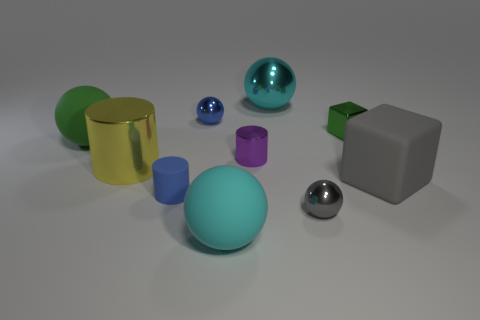What material is the purple object?
Give a very brief answer. Metal. What number of matte balls are behind the large metallic thing behind the small purple metal thing?
Your response must be concise. 0. There is a rubber cylinder; does it have the same color as the small metal ball behind the large green matte sphere?
Offer a terse response. Yes. There is a rubber cube that is the same size as the cyan shiny object; what is its color?
Keep it short and to the point. Gray. Are there any cyan objects of the same shape as the tiny blue metal object?
Your response must be concise. Yes. Is the number of big green spheres less than the number of yellow balls?
Provide a succinct answer. No. What is the color of the tiny cylinder that is behind the gray rubber cube?
Make the answer very short. Purple. There is a large metal object left of the big cyan ball behind the big yellow cylinder; what is its shape?
Your answer should be very brief. Cylinder. Is the large gray cube made of the same material as the tiny blue object that is behind the green metallic cube?
Ensure brevity in your answer.  No. What shape is the metallic object that is the same color as the small matte object?
Keep it short and to the point. Sphere. 